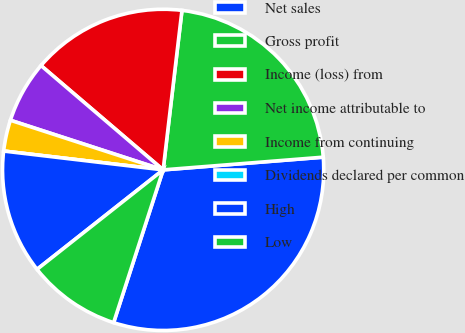<chart> <loc_0><loc_0><loc_500><loc_500><pie_chart><fcel>Net sales<fcel>Gross profit<fcel>Income (loss) from<fcel>Net income attributable to<fcel>Income from continuing<fcel>Dividends declared per common<fcel>High<fcel>Low<nl><fcel>31.25%<fcel>21.87%<fcel>15.62%<fcel>6.25%<fcel>3.13%<fcel>0.0%<fcel>12.5%<fcel>9.38%<nl></chart> 